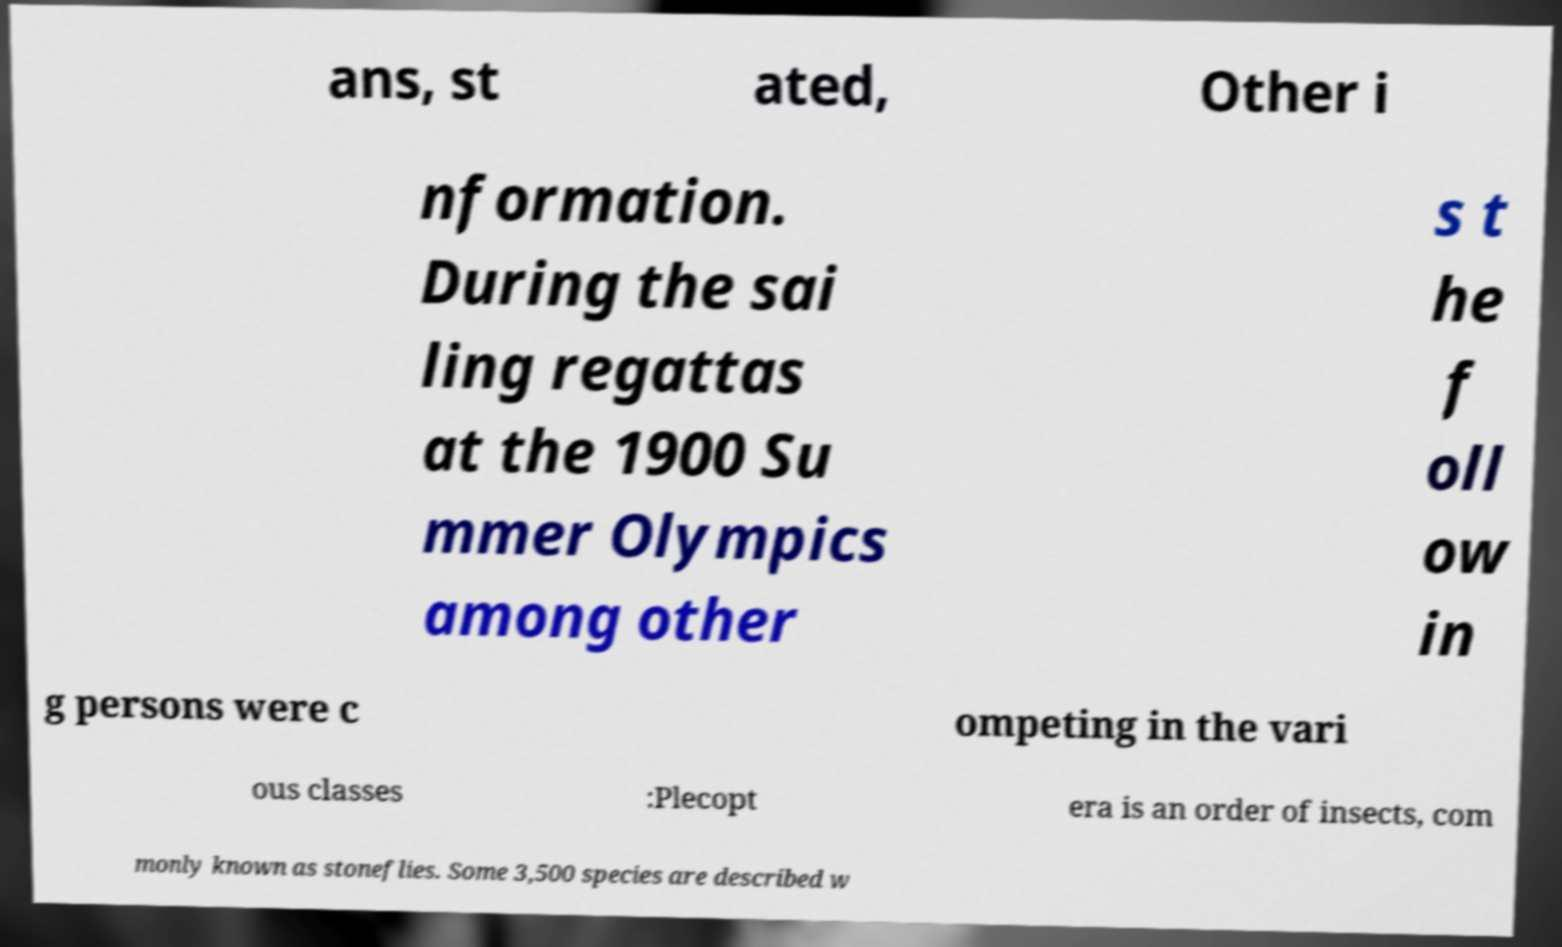Please read and relay the text visible in this image. What does it say? ans, st ated, Other i nformation. During the sai ling regattas at the 1900 Su mmer Olympics among other s t he f oll ow in g persons were c ompeting in the vari ous classes :Plecopt era is an order of insects, com monly known as stoneflies. Some 3,500 species are described w 